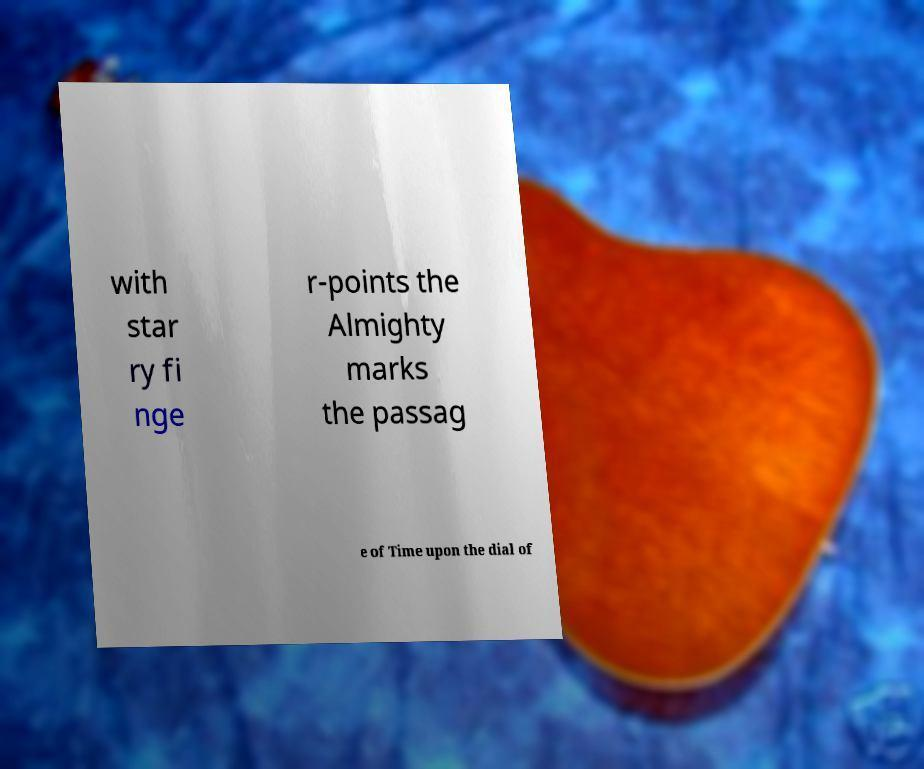There's text embedded in this image that I need extracted. Can you transcribe it verbatim? with star ry fi nge r-points the Almighty marks the passag e of Time upon the dial of 